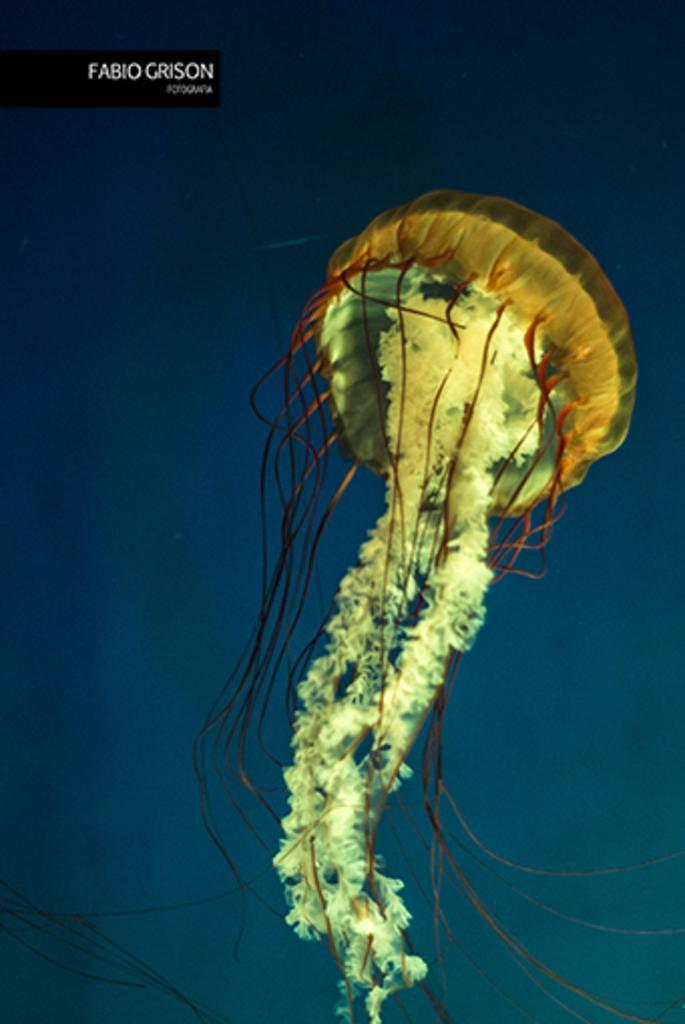Could you give a brief overview of what you see in this image? In the image we can see water, in the water we can see a jellyfish. 